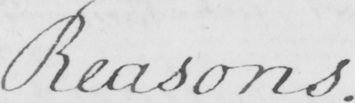Transcribe the text shown in this historical manuscript line. Reasons . 